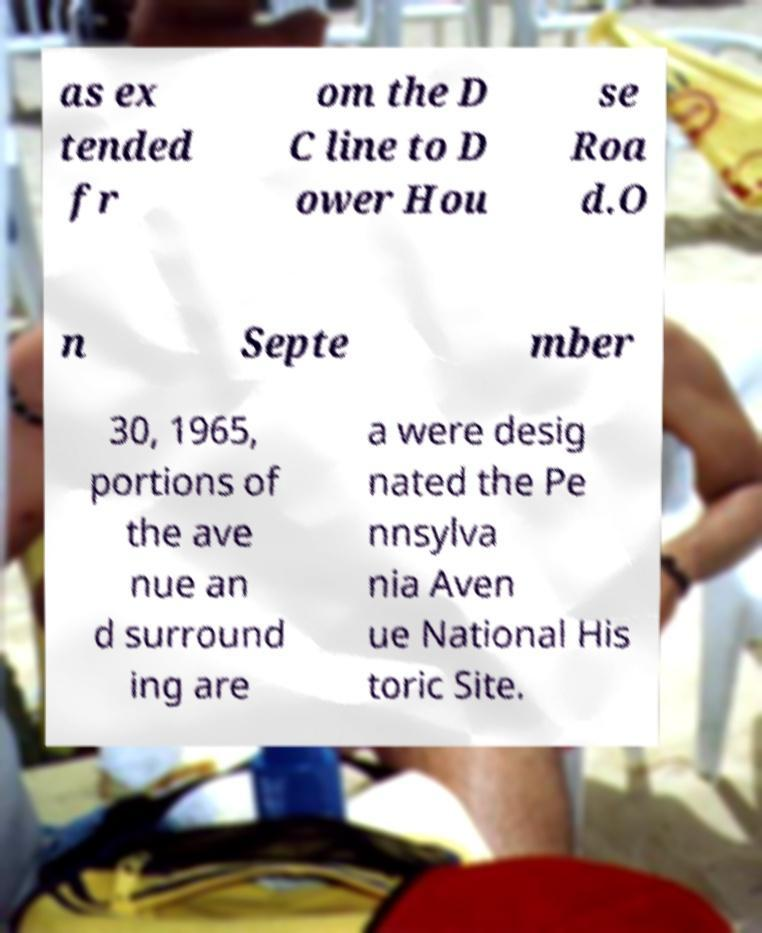Could you extract and type out the text from this image? as ex tended fr om the D C line to D ower Hou se Roa d.O n Septe mber 30, 1965, portions of the ave nue an d surround ing are a were desig nated the Pe nnsylva nia Aven ue National His toric Site. 